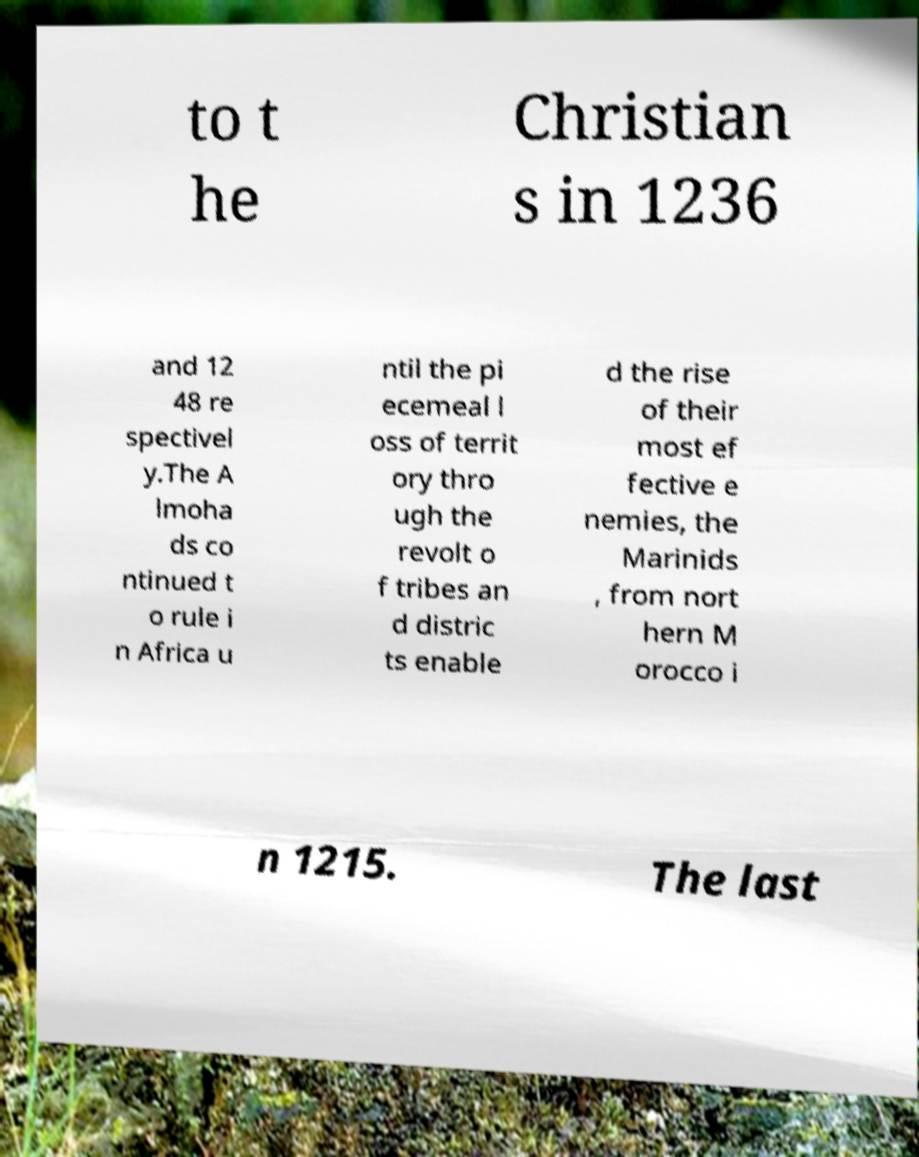I need the written content from this picture converted into text. Can you do that? to t he Christian s in 1236 and 12 48 re spectivel y.The A lmoha ds co ntinued t o rule i n Africa u ntil the pi ecemeal l oss of territ ory thro ugh the revolt o f tribes an d distric ts enable d the rise of their most ef fective e nemies, the Marinids , from nort hern M orocco i n 1215. The last 